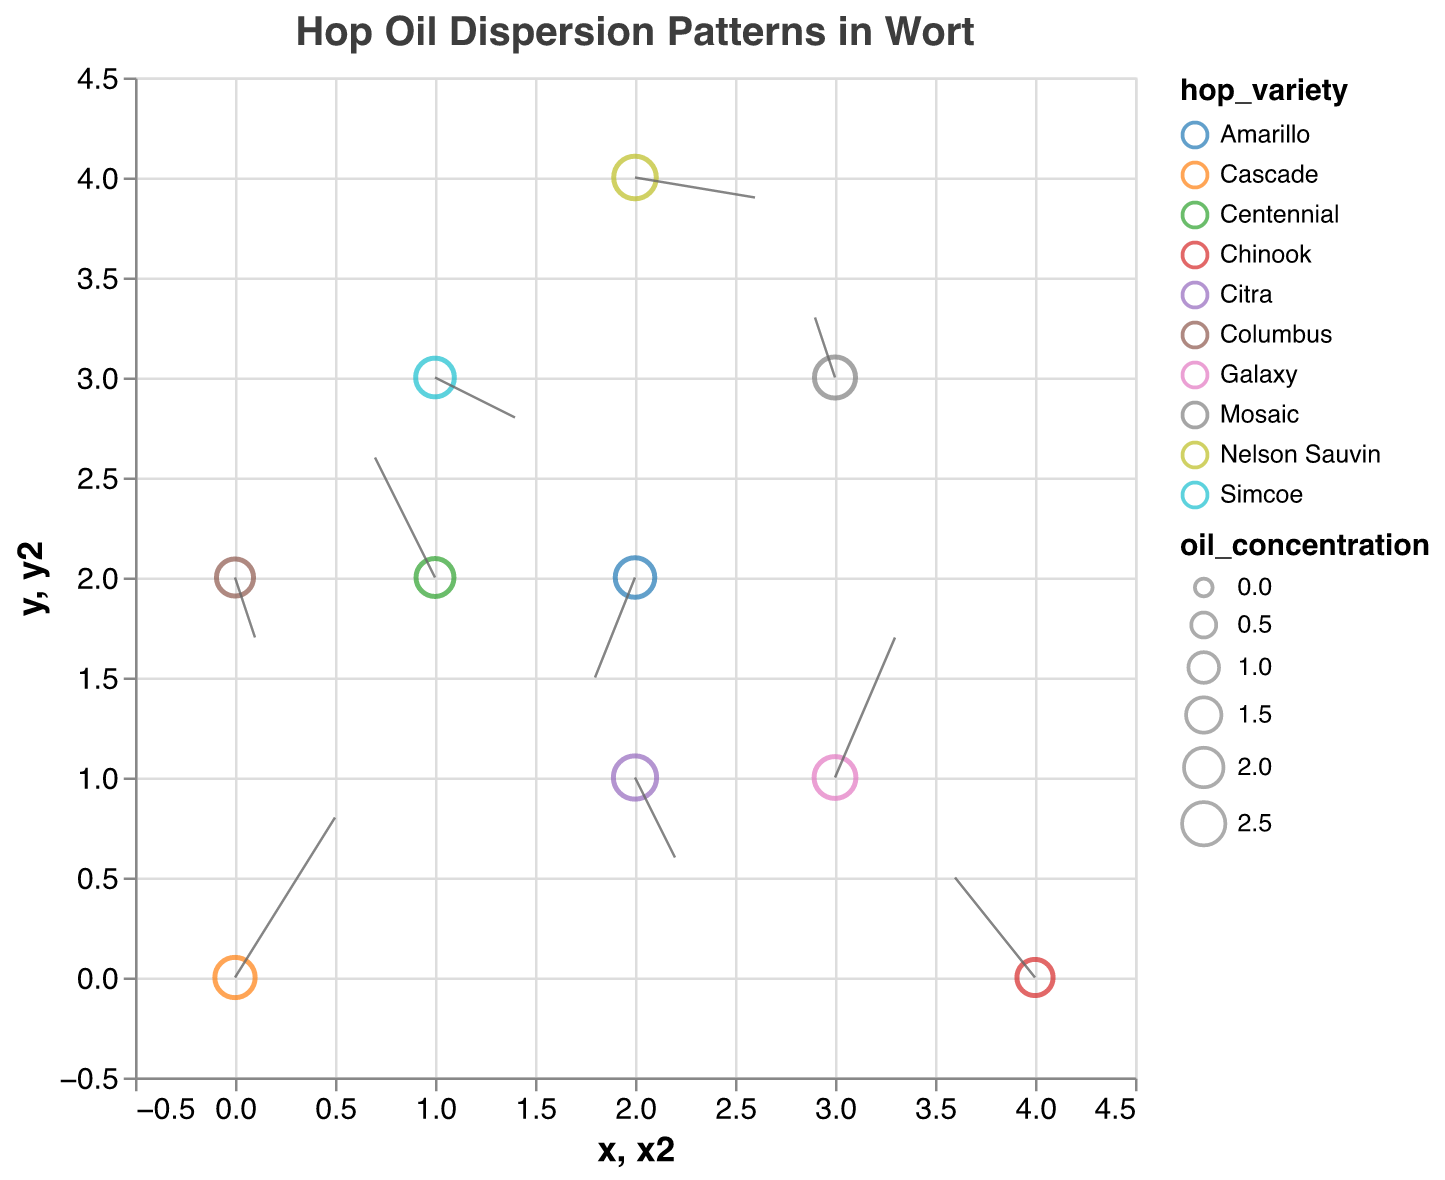Which hop variety has the highest oil concentration? We observe the size of the points in the quiver plot, as larger points indicate higher oil concentration. The largest point corresponds to Citra.
Answer: Citra What is the direction of oil dispersion for Galaxy? By observing the vector (arrows) for Galaxy at the coordinates (3, 1), we see it points towards the right and upward.
Answer: Right and upward How many hop varieties have an oil concentration greater than 2.0? From the plot, the hop varieties with oil concentrations greater than 2.0 are Cascade, Citra, Mosaic, Galaxy, and Nelson Sauvin. Counting these gives us 5.
Answer: 5 What is the position of Simcoe on the plot? The plot shows Simcoe positioned at coordinates (1, 3).
Answer: (1, 3) Which hop variety has the vector pointing most downward? By examining the direction of the vectors in the plot, Amarillo has a vector pointing most downward at coordinates (2, 2), as its vertical component (v) is -0.5, the most negative among the downward vectors.
Answer: Amarillo What is the average oil concentration of the hop varieties that have vectors pointing leftward? The hop varieties with u < 0 (leftward-pointing vectors) are Centennial, Amarillo, and Chinook with oil concentrations 1.8, 2.0, 1.6 respectively. The average oil concentration is calculated as (1.8 + 2.0 + 1.6) / 3 = 1.8.
Answer: 1.8 Compare the oil concentration of Cascade and Nelson Sauvin. Cascade has an oil concentration of 2.1 and Nelson Sauvin has 2.4. Nelson Sauvin has a higher oil concentration.
Answer: Nelson Sauvin has a higher oil concentration Which hop variety is located at the highest y-coordinate? From the plot, the hop variety at the highest y-coordinate (4) is Nelson Sauvin.
Answer: Nelson Sauvin How does the dispersion pattern of Centennial compare to Simcoe in terms of direction and magnitude? Centennial at (1, 2) has a leftward (u = -0.3) and upward (v = 0.6) vector. Simcoe at (1, 3) has a rightward (u = 0.4) and downward (v = -0.2) vector. Centennial disperses more vertically and to the left, while Simcoe disperses horizontally and to the right.
Answer: Centennial: left and up, Simcoe: right and down What is the oil concentration range represented in the plot? By identifying the smallest and largest oil concentration values from the data, we find the lowest is Columbus with 1.7 and the highest is Citra with 2.5. Thus, the range is from 1.6 to 2.5.
Answer: 1.6 to 2.5 